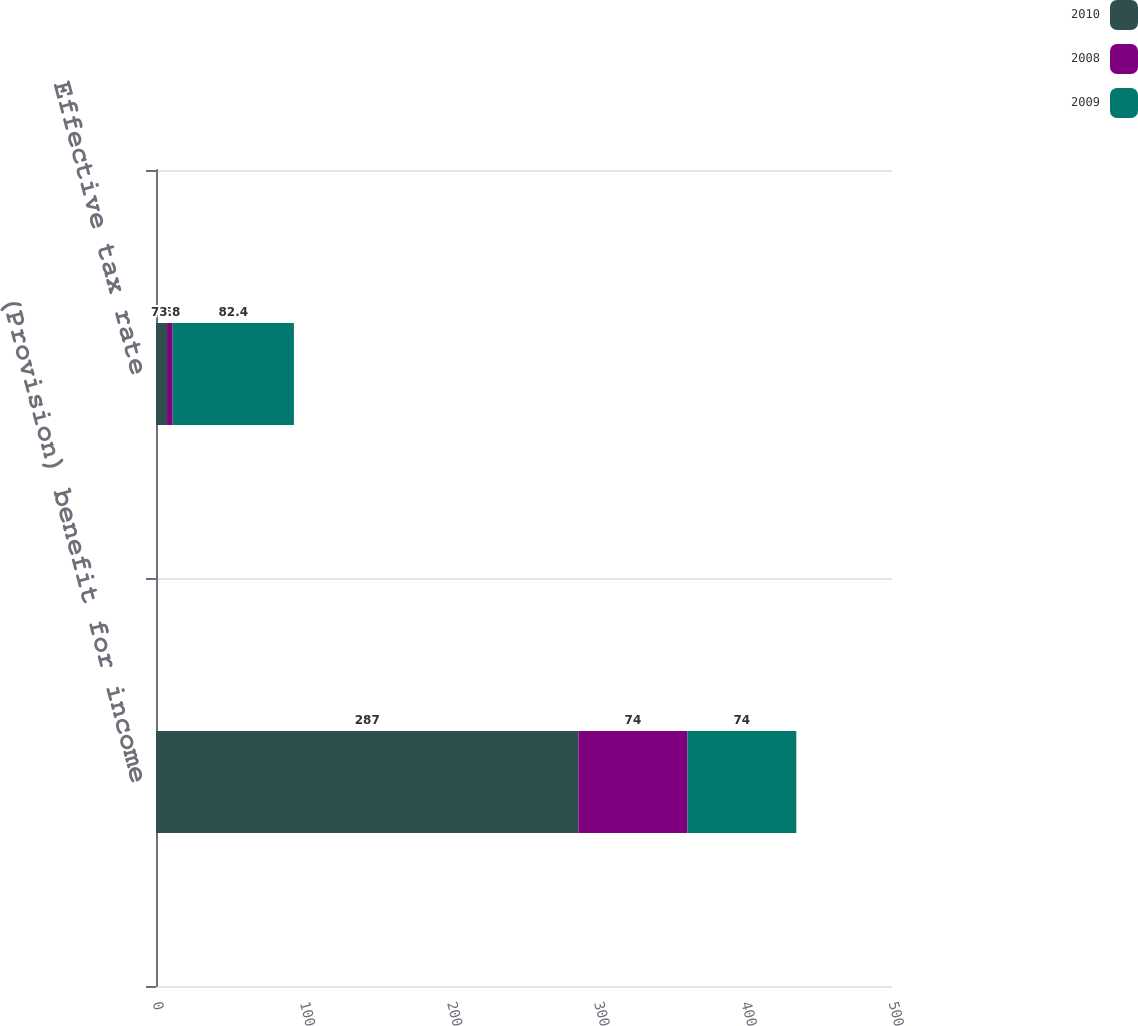Convert chart. <chart><loc_0><loc_0><loc_500><loc_500><stacked_bar_chart><ecel><fcel>(Provision) benefit for income<fcel>Effective tax rate<nl><fcel>2010<fcel>287<fcel>7.5<nl><fcel>2008<fcel>74<fcel>3.8<nl><fcel>2009<fcel>74<fcel>82.4<nl></chart> 